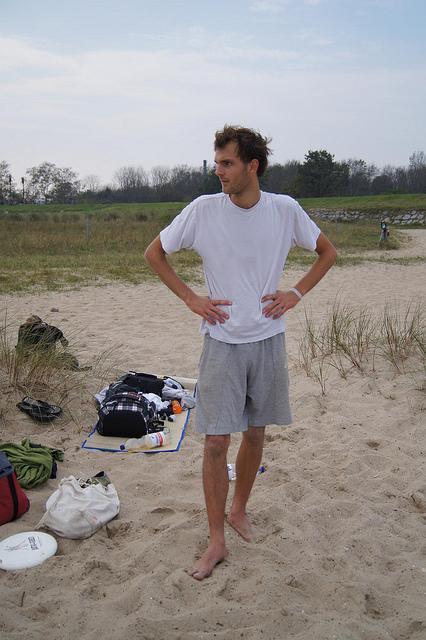How many legs is the man standing on?
Give a very brief answer. 2. How many people are visible?
Give a very brief answer. 2. How many backpacks are there?
Give a very brief answer. 2. 